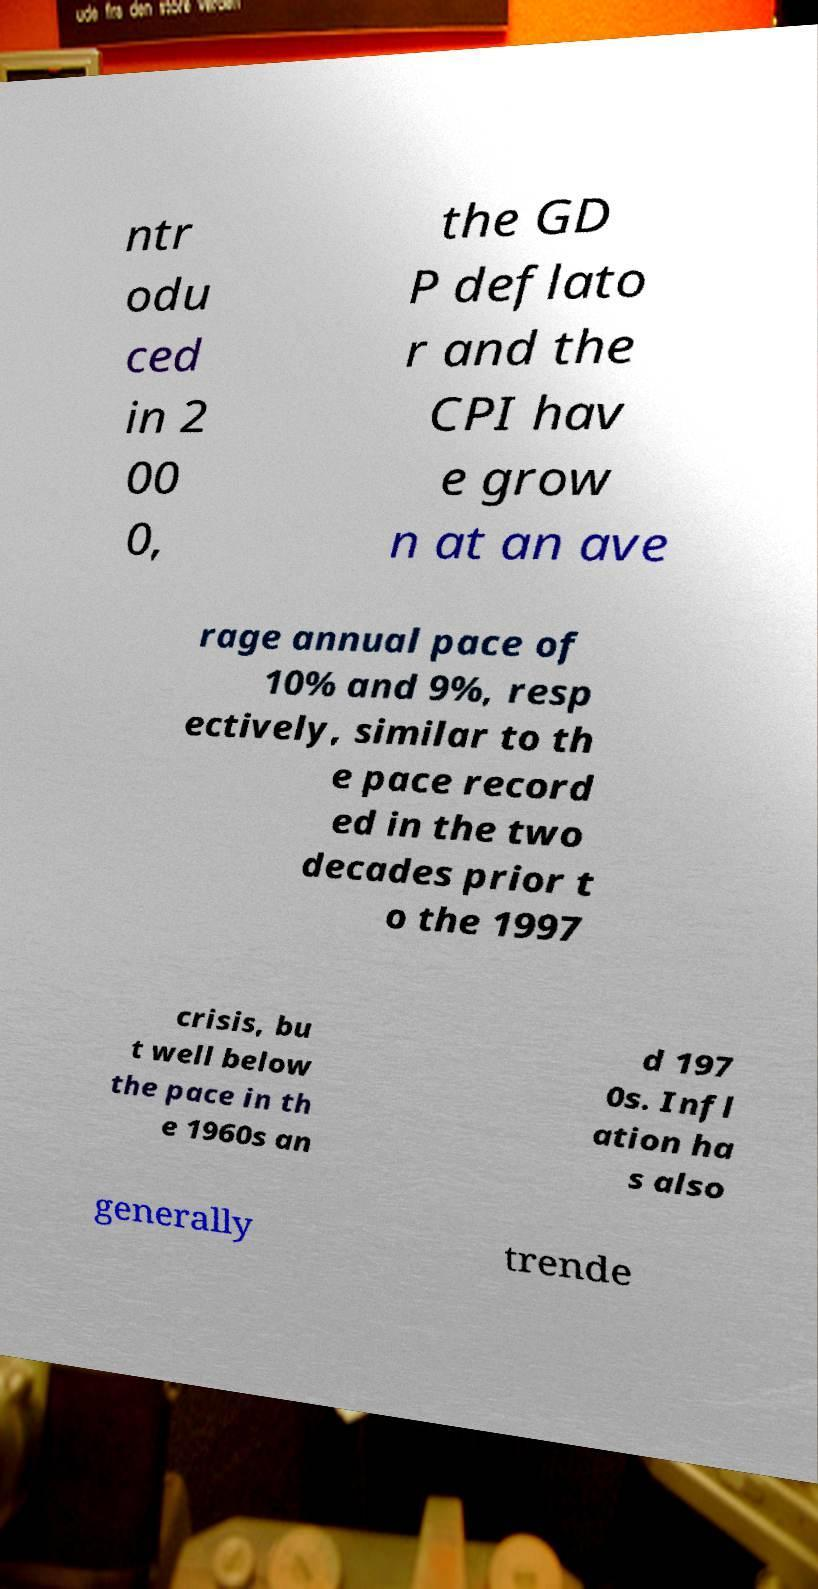I need the written content from this picture converted into text. Can you do that? ntr odu ced in 2 00 0, the GD P deflato r and the CPI hav e grow n at an ave rage annual pace of 10% and 9%, resp ectively, similar to th e pace record ed in the two decades prior t o the 1997 crisis, bu t well below the pace in th e 1960s an d 197 0s. Infl ation ha s also generally trende 